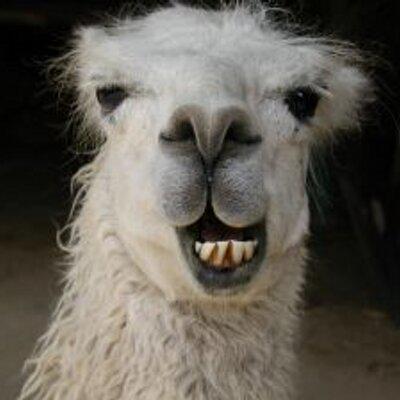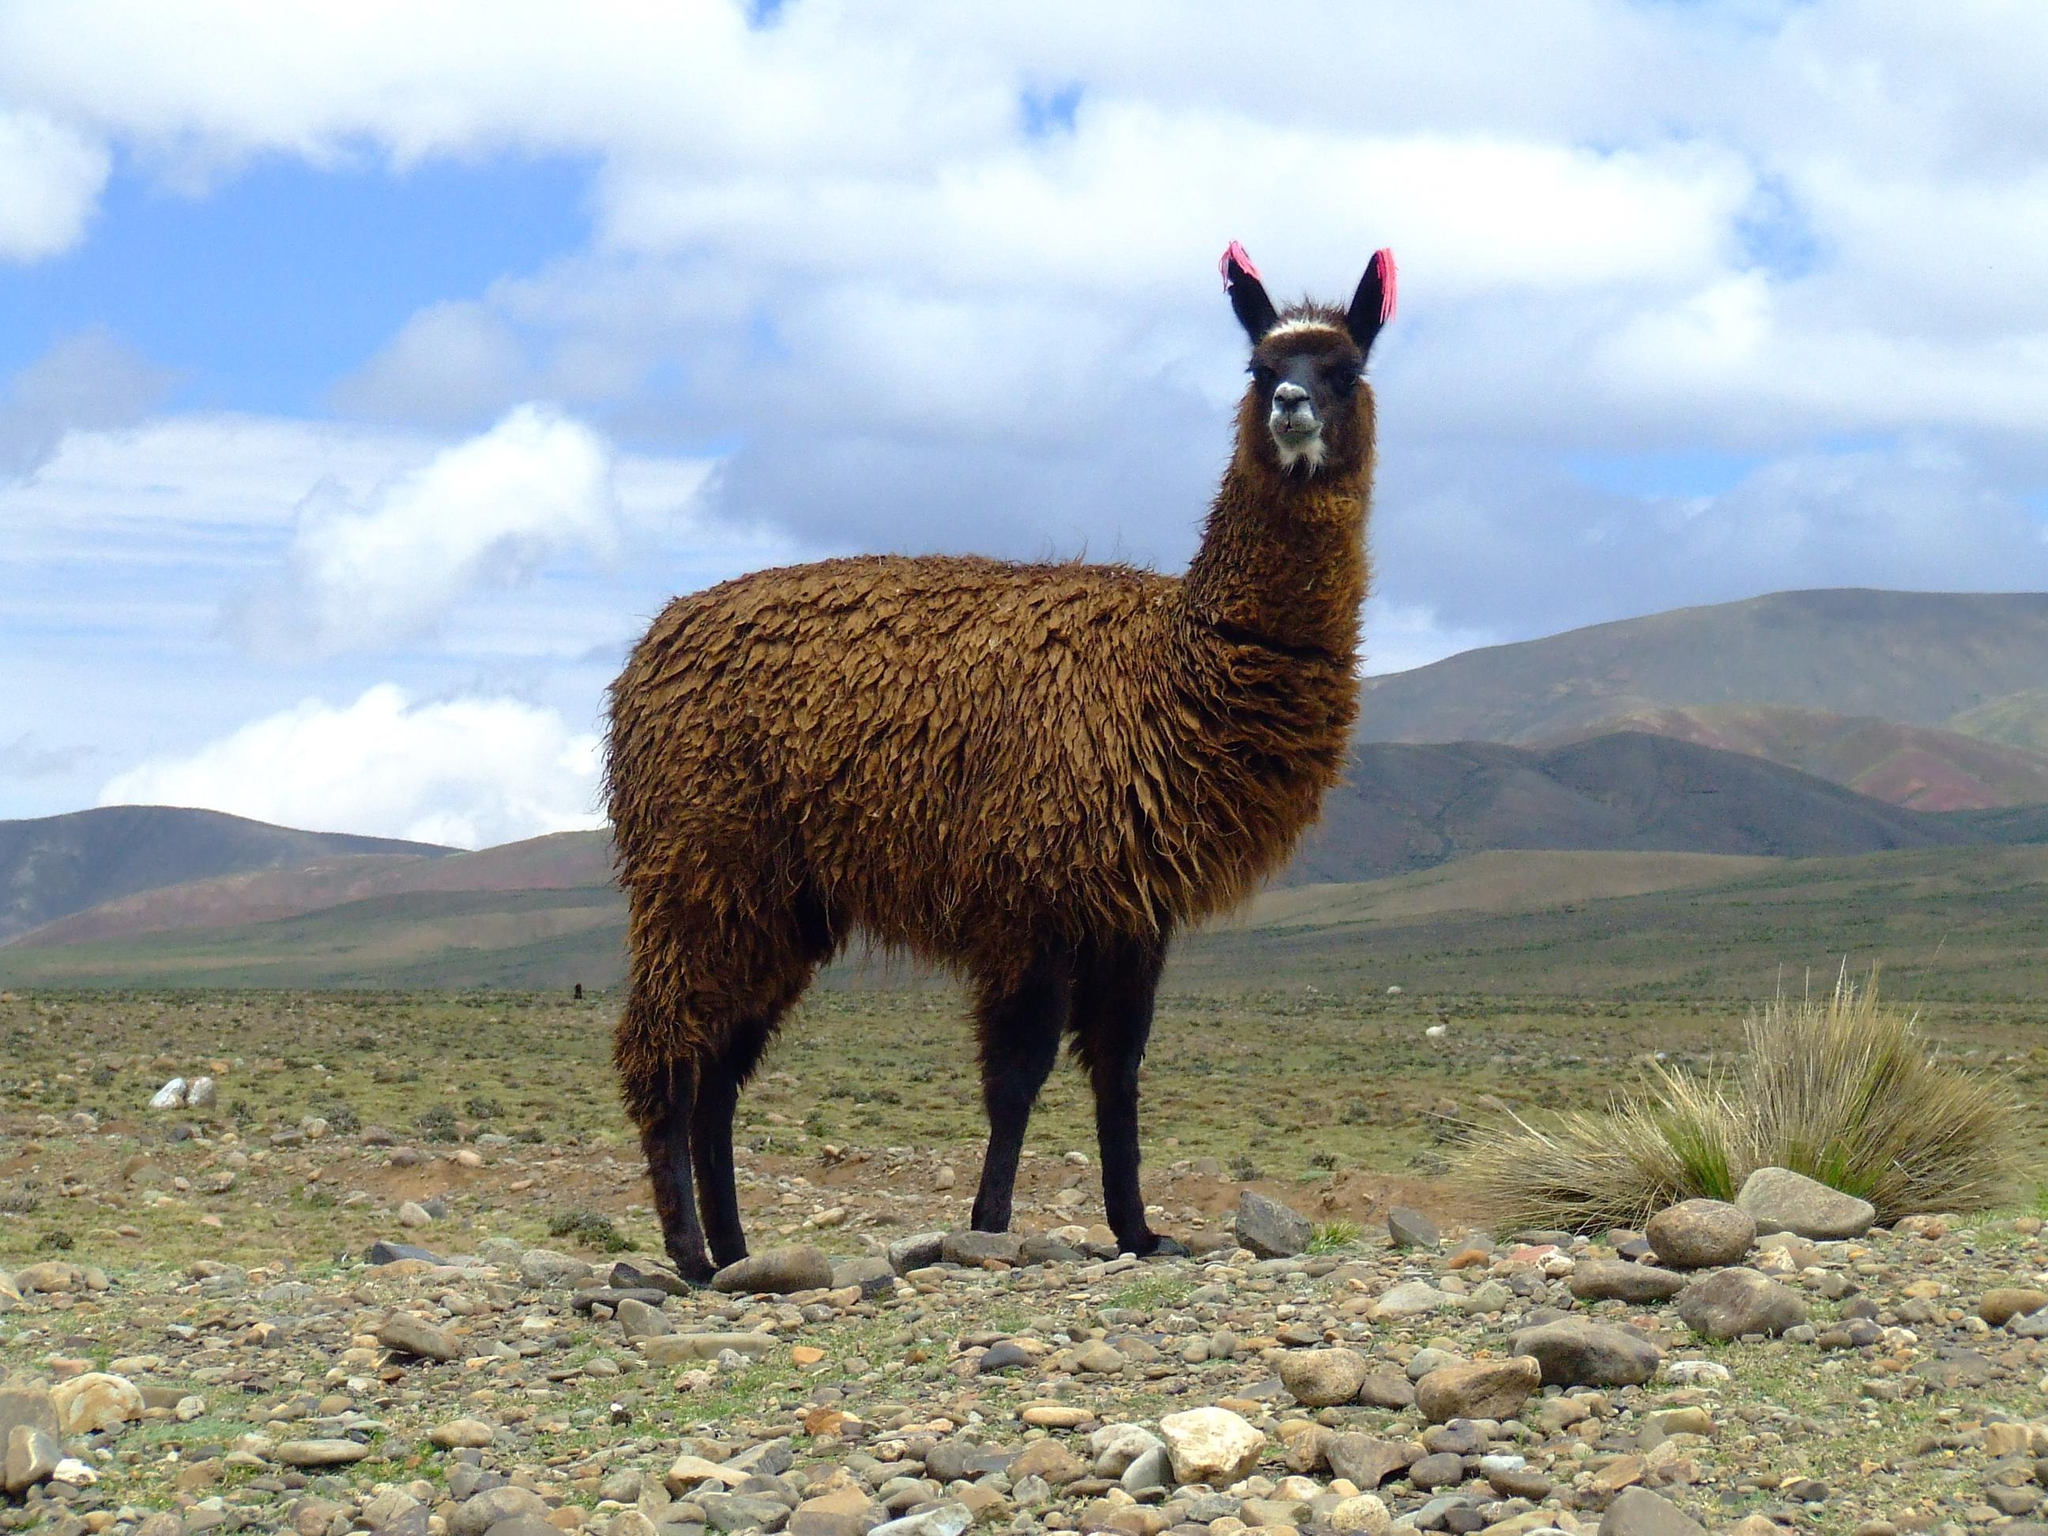The first image is the image on the left, the second image is the image on the right. Analyze the images presented: Is the assertion "An image features a white forward-facing llama showing its protruding lower teeth." valid? Answer yes or no. Yes. The first image is the image on the left, the second image is the image on the right. Given the left and right images, does the statement "The left and right image contains the same number of llamas." hold true? Answer yes or no. Yes. 